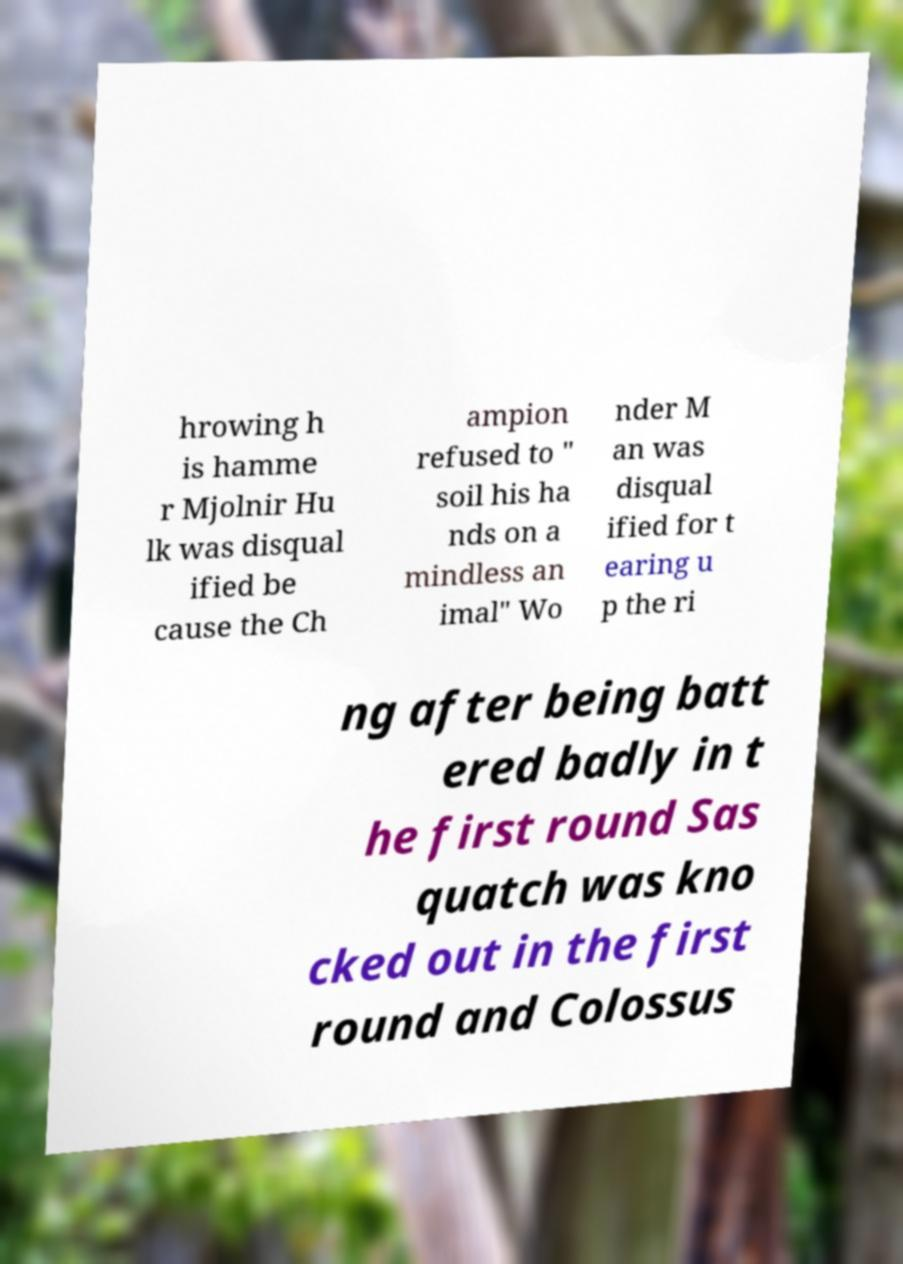Could you assist in decoding the text presented in this image and type it out clearly? hrowing h is hamme r Mjolnir Hu lk was disqual ified be cause the Ch ampion refused to " soil his ha nds on a mindless an imal" Wo nder M an was disqual ified for t earing u p the ri ng after being batt ered badly in t he first round Sas quatch was kno cked out in the first round and Colossus 